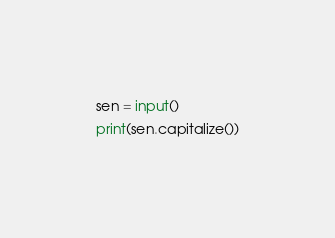Convert code to text. <code><loc_0><loc_0><loc_500><loc_500><_Python_>sen = input()
print(sen.capitalize())
</code> 